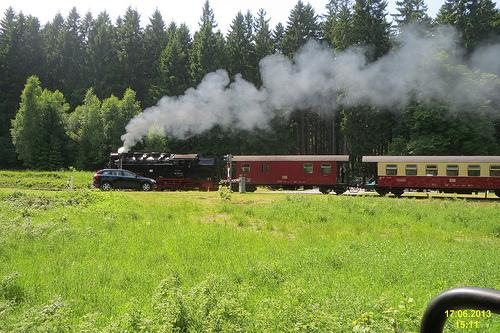What is the color of the train and what is it doing in the image? The train is black and red, and it is moving on railroad tracks beside a black car. What kind of sentiment or emotion can be inferred from the image based on the visual elements present? The sentiment of the image is likely serene and calm, as it shows a train moving through a picturesque rural landscape with passengers enjoying the scenic view. Identify the presence and role of any people in the image. A conductor is standing on the train platform, and passengers are enjoying the scenery from inside the train. Mention any non-living objects in the image that hold significance or relevance. The black handle to a motor vehicle, rusty brown metal pole, crossing signal arm, and train stop area sign are significant non-living objects in the image. Explain any instances of anomalies or unusual occurrences within the image. There is a camera date time stamp and yellow text time stamp included in the image, which may be considered as unusual occurrences or anomalies. What is the primary mode of transportation depicted in the image, and what can you observe about it? The primary mode of transportation is a train, which is long in size and has a steam engine with white smoke billowing from it. What type of objects are in the background of the image, and how would you describe them? In the background, there are tall pine tree forests, weeds on the ground, and a crossing signal arm down near a train stop area sign. What is happening in the image, and how do the elements interact with each other? A train is moving on tracks beside a parked black car, while white steam is released from the engine and passengers enjoy the scenic landscape of grass, trees, and dirt roads. Describe the surrounding environment in the image. There are tall trees with green leaves, a green field of grass, a grassy meadow with lush bushes, and a dirt road alongside the tracks. Express the scene through a poetic lens, emphasizing the subjects and their interactions. A long train, with colors of black and red, journeys across a rural world where green grasses sway and tall trees guard, as passengers marvel in nature's embrace. Describe a serene scene with a train passing by a field. The train glides gracefully on tracks abuzz with life, as it passes through a vast field adorned with green grass swaying gently in the breeze. Is the train in motion or stationary? Moving What does the smoke from the train look like? White and billowing Do the trees have any specific features mentioned? Tall with green leaves What is the state of the grass in the information provided? Long and green What is the color and length of the trees? Green and tall What is the overall color of the grass in the image? Green Identify the height of the trees. Tall What is the activity involving the train and the car in the image? Train moving on tracks beside the car Describe the scenery around the train. Green grass, tall trees, and a dirt road alongside tracks What is the color and shape of the train stop sign? Not mentioned Is there a crossing signal in the image information? Yes, crossing signal arm down Create a description of a scene where a train is moving on tracks beside a black car surrounded by green grass and tall trees. A black train moves speedily along railroad tracks, parallel to a black car driving through lush green meadows, as tall trees frame the picturesque scene. What is the color of the car parked beside the train?  Black Identify the vehicle beside the train. Car Provide a brief description of the scene with the train and car. Train moving on tracks beside a black car, surrounded by tall trees and green grass. Is there anything mentioned about the train passengers in the image information? Yes, they enjoy the scenery 